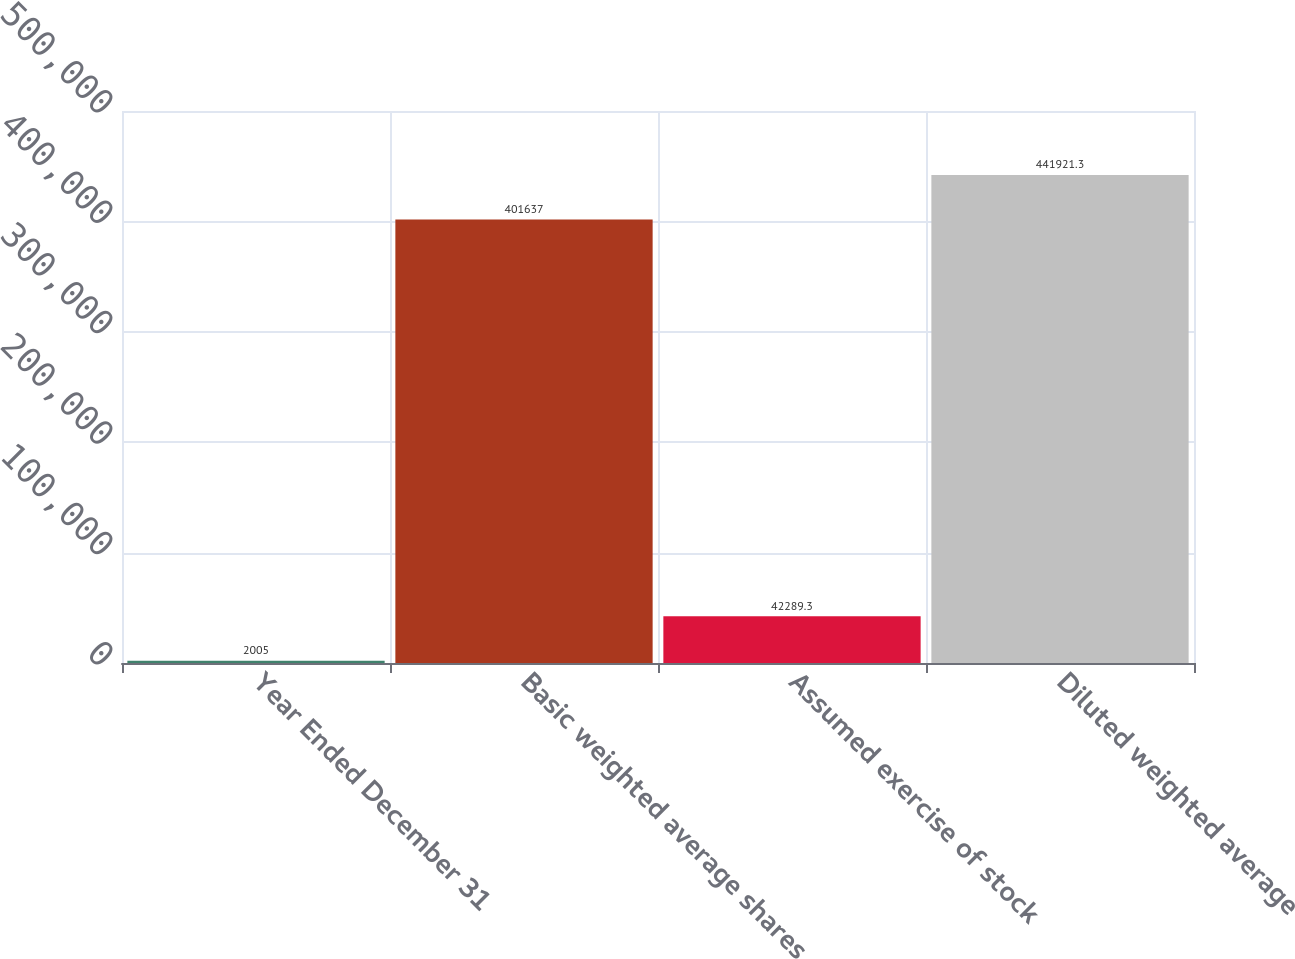Convert chart. <chart><loc_0><loc_0><loc_500><loc_500><bar_chart><fcel>Year Ended December 31<fcel>Basic weighted average shares<fcel>Assumed exercise of stock<fcel>Diluted weighted average<nl><fcel>2005<fcel>401637<fcel>42289.3<fcel>441921<nl></chart> 